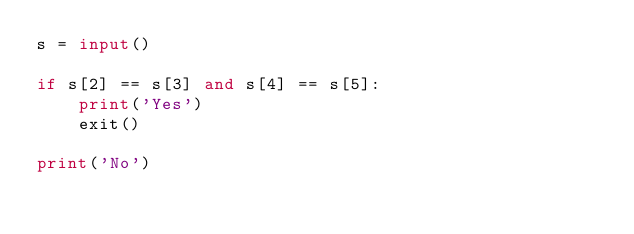Convert code to text. <code><loc_0><loc_0><loc_500><loc_500><_Python_>s = input()

if s[2] == s[3] and s[4] == s[5]:
    print('Yes')
    exit()

print('No')</code> 